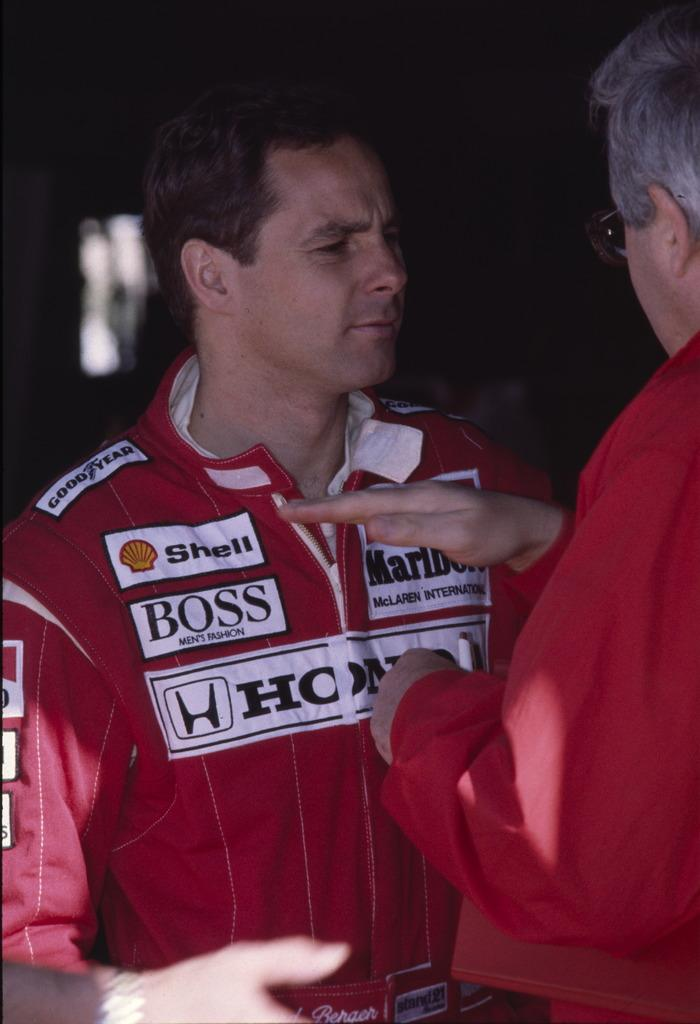<image>
Create a compact narrative representing the image presented. A racecar driver is sponsored by Boss, Shell, and Honda. 